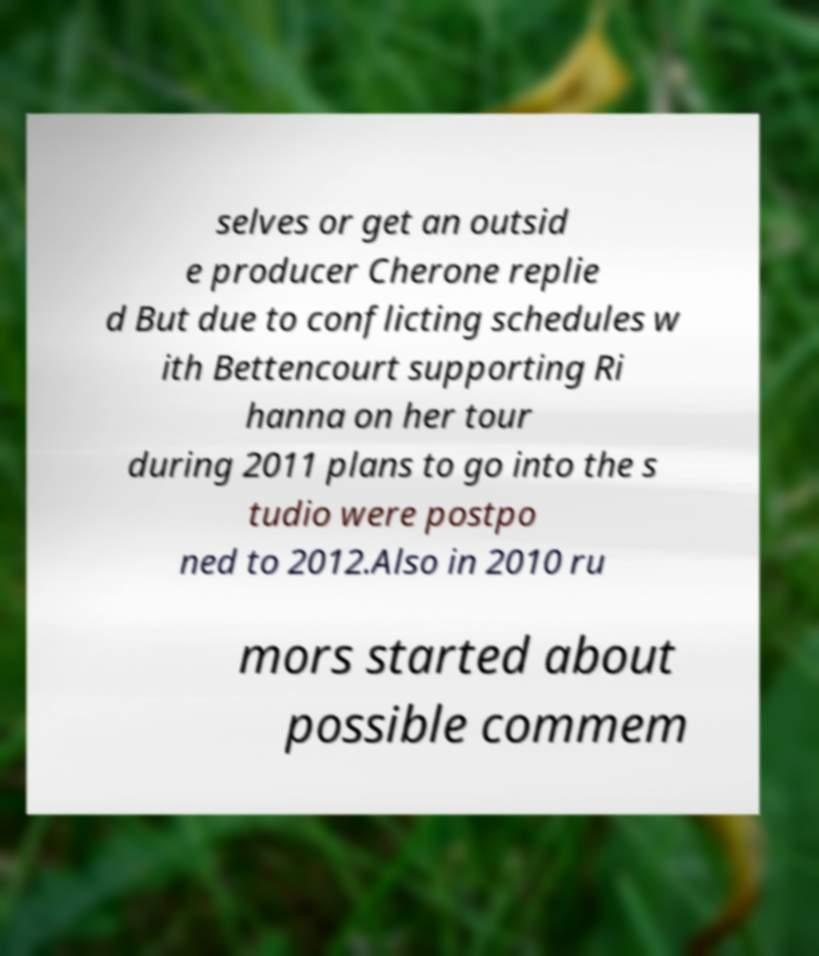Could you assist in decoding the text presented in this image and type it out clearly? selves or get an outsid e producer Cherone replie d But due to conflicting schedules w ith Bettencourt supporting Ri hanna on her tour during 2011 plans to go into the s tudio were postpo ned to 2012.Also in 2010 ru mors started about possible commem 